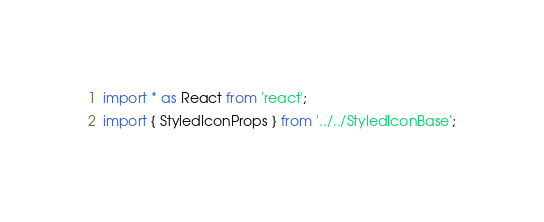Convert code to text. <code><loc_0><loc_0><loc_500><loc_500><_TypeScript_>import * as React from 'react';
import { StyledIconProps } from '../../StyledIconBase';</code> 